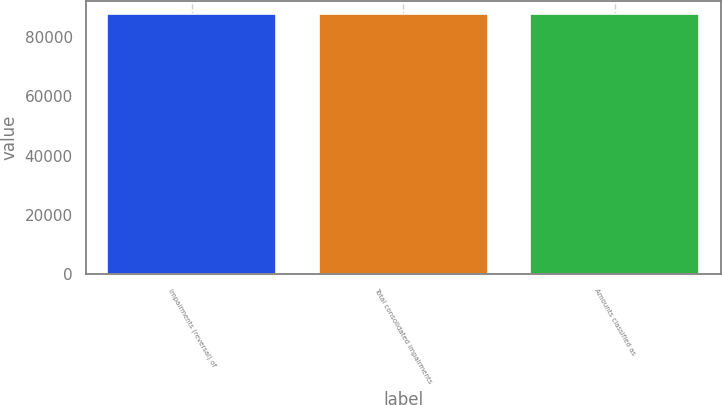Convert chart to OTSL. <chart><loc_0><loc_0><loc_500><loc_500><bar_chart><fcel>Impairments (reversal) of<fcel>Total consolidated impairments<fcel>Amounts classified as<nl><fcel>87613<fcel>87613.8<fcel>87605<nl></chart> 